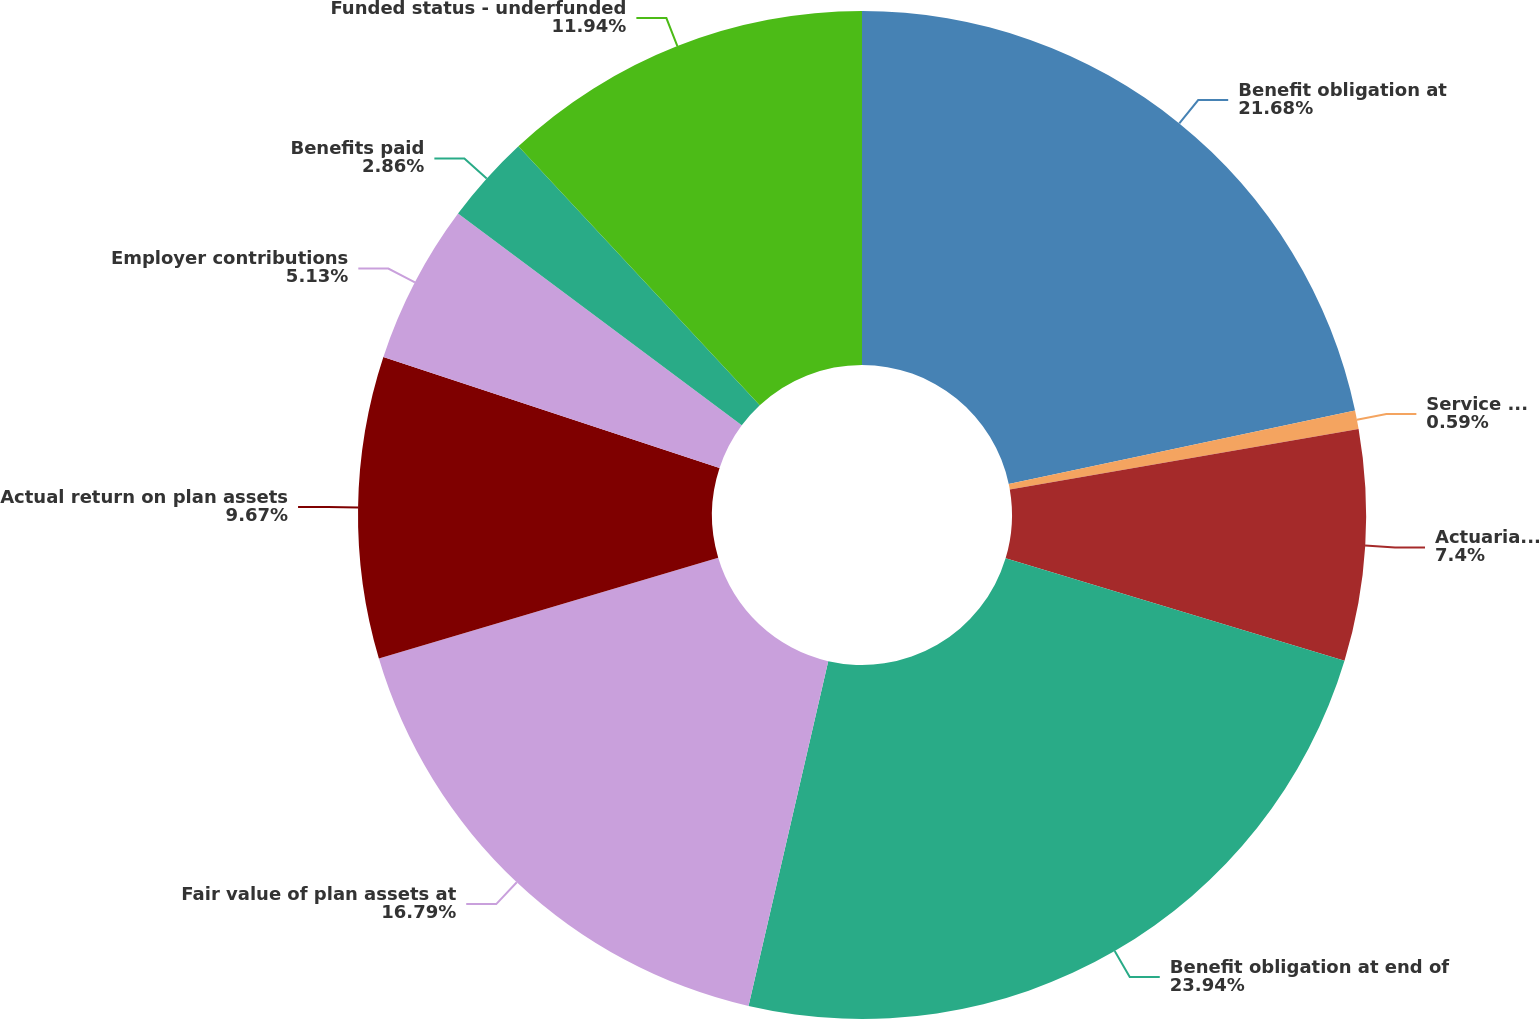Convert chart. <chart><loc_0><loc_0><loc_500><loc_500><pie_chart><fcel>Benefit obligation at<fcel>Service cost<fcel>Actuarial loss (gain)<fcel>Benefit obligation at end of<fcel>Fair value of plan assets at<fcel>Actual return on plan assets<fcel>Employer contributions<fcel>Benefits paid<fcel>Funded status - underfunded<nl><fcel>21.68%<fcel>0.59%<fcel>7.4%<fcel>23.95%<fcel>16.79%<fcel>9.67%<fcel>5.13%<fcel>2.86%<fcel>11.94%<nl></chart> 